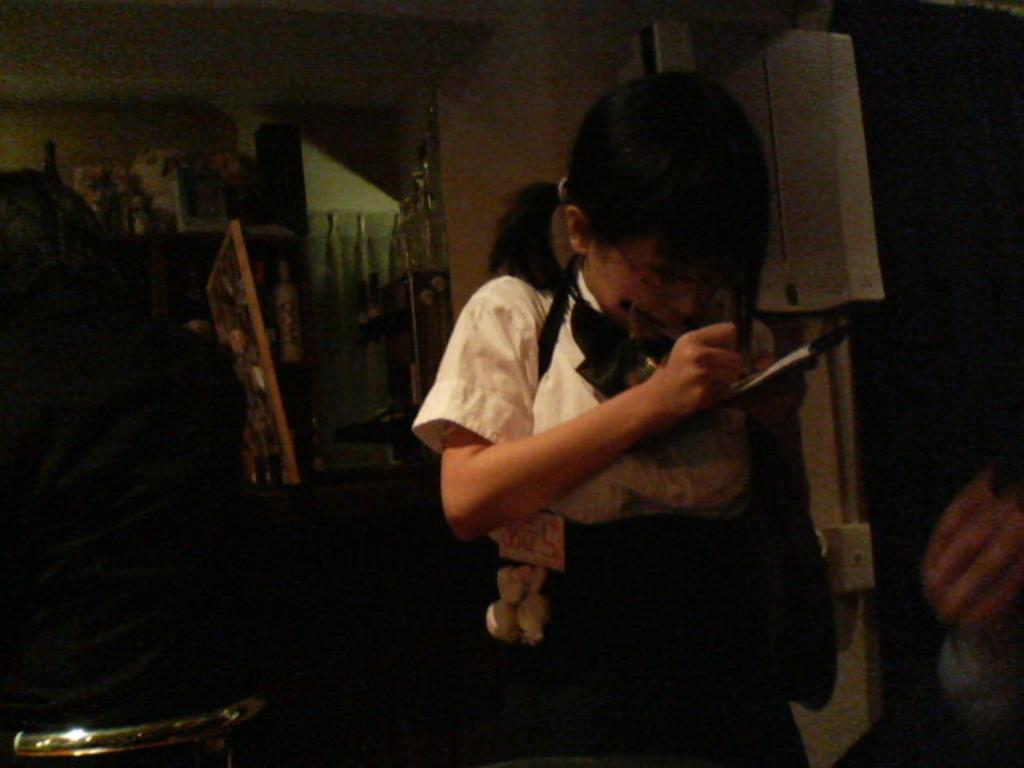What is the girl in the image doing? The girl is standing in the image and holding a paper in her hand. Can you describe the other person in the image? There is a person sitting on a chair in the image. What is the overall lighting condition in the image? The background of the image is slightly dark. Can you tell me how many deer are visible in the image? There are no deer present in the image. What type of alarm is the girl using in the image? There is no alarm present in the image. 